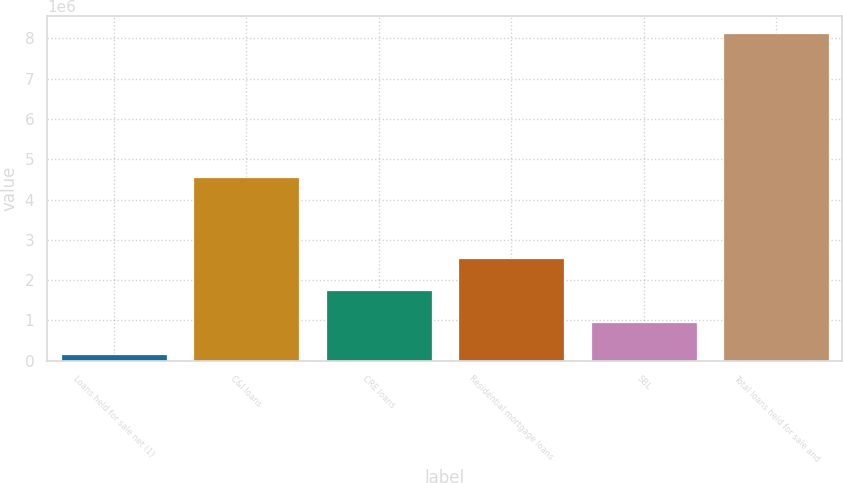Convert chart. <chart><loc_0><loc_0><loc_500><loc_500><bar_chart><fcel>Loans held for sale net (1)<fcel>C&I loans<fcel>CRE loans<fcel>Residential mortgage loans<fcel>SBL<fcel>Total loans held for sale and<nl><fcel>160515<fcel>4.55306e+06<fcel>1.75622e+06<fcel>2.55408e+06<fcel>958369<fcel>8.13905e+06<nl></chart> 